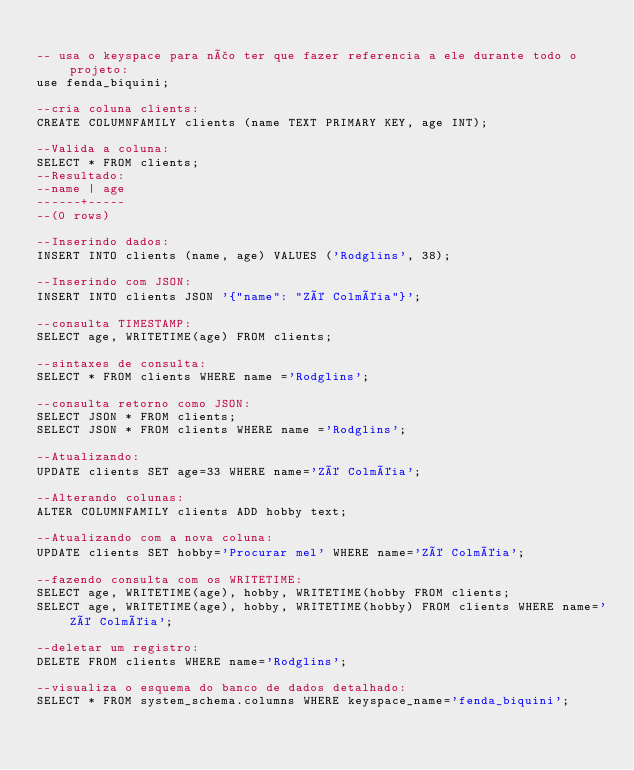<code> <loc_0><loc_0><loc_500><loc_500><_SQL_>
-- usa o keyspace para não ter que fazer referencia a ele durante todo o projeto:
use fenda_biquini; 

--cria coluna clients:
CREATE COLUMNFAMILY clients (name TEXT PRIMARY KEY, age INT);

--Valida a coluna:
SELECT * FROM clients;
--Resultado:  
--name | age
------+-----
--(0 rows)

--Inserindo dados:
INSERT INTO clients (name, age) VALUES ('Rodglins', 38);

--Inserindo com JSON:
INSERT INTO clients JSON '{"name": "Zé Colméia"}';

--consulta TIMESTAMP:
SELECT age, WRITETIME(age) FROM clients;

--sintaxes de consulta:
SELECT * FROM clients WHERE name ='Rodglins';

--consulta retorno como JSON:
SELECT JSON * FROM clients;
SELECT JSON * FROM clients WHERE name ='Rodglins';

--Atualizando:
UPDATE clients SET age=33 WHERE name='Zé Colméia';

--Alterando colunas:
ALTER COLUMNFAMILY clients ADD hobby text;

--Atualizando com a nova coluna:
UPDATE clients SET hobby='Procurar mel' WHERE name='Zé Colméia';

--fazendo consulta com os WRITETIME:
SELECT age, WRITETIME(age), hobby, WRITETIME(hobby FROM clients;
SELECT age, WRITETIME(age), hobby, WRITETIME(hobby) FROM clients WHERE name='Zé Colméia';

--deletar um registro:
DELETE FROM clients WHERE name='Rodglins';

--visualiza o esquema do banco de dados detalhado:
SELECT * FROM system_schema.columns WHERE keyspace_name='fenda_biquini';</code> 